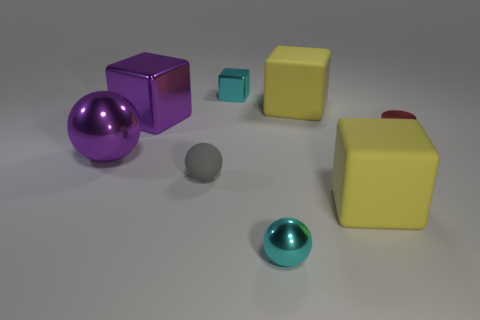What is the size of the sphere that is behind the tiny metallic sphere and in front of the big metallic ball?
Your response must be concise. Small. Are there any other things of the same color as the small rubber ball?
Ensure brevity in your answer.  No. What is the size of the purple block behind the tiny cyan metal object that is in front of the big purple shiny cube?
Give a very brief answer. Large. There is a large object that is both right of the purple block and behind the tiny matte ball; what is its color?
Offer a terse response. Yellow. What number of other objects are the same size as the shiny cylinder?
Your answer should be very brief. 3. There is a purple metal block; is its size the same as the matte block in front of the small red shiny cylinder?
Provide a succinct answer. Yes. The other metal ball that is the same size as the gray ball is what color?
Ensure brevity in your answer.  Cyan. The cylinder is what size?
Keep it short and to the point. Small. Do the small cyan thing that is on the left side of the cyan metal ball and the small red object have the same material?
Provide a short and direct response. Yes. There is a cyan object behind the large yellow cube that is on the left side of the large yellow block that is in front of the purple metal block; what is its shape?
Keep it short and to the point. Cube. 